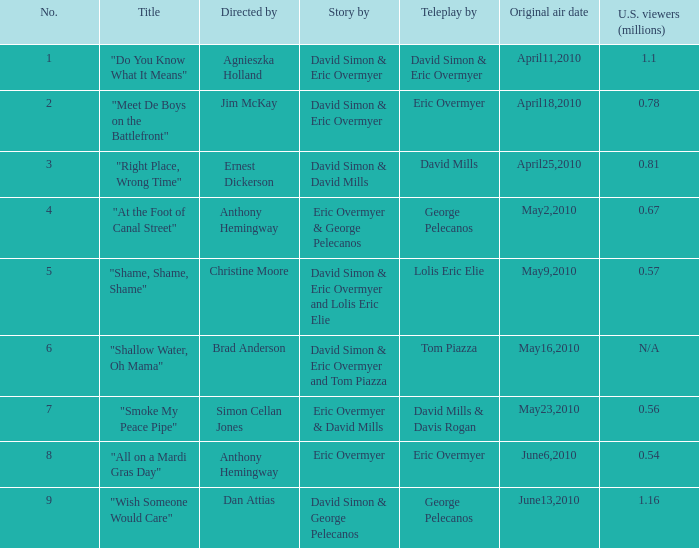Name the number for simon cellan jones 7.0. 